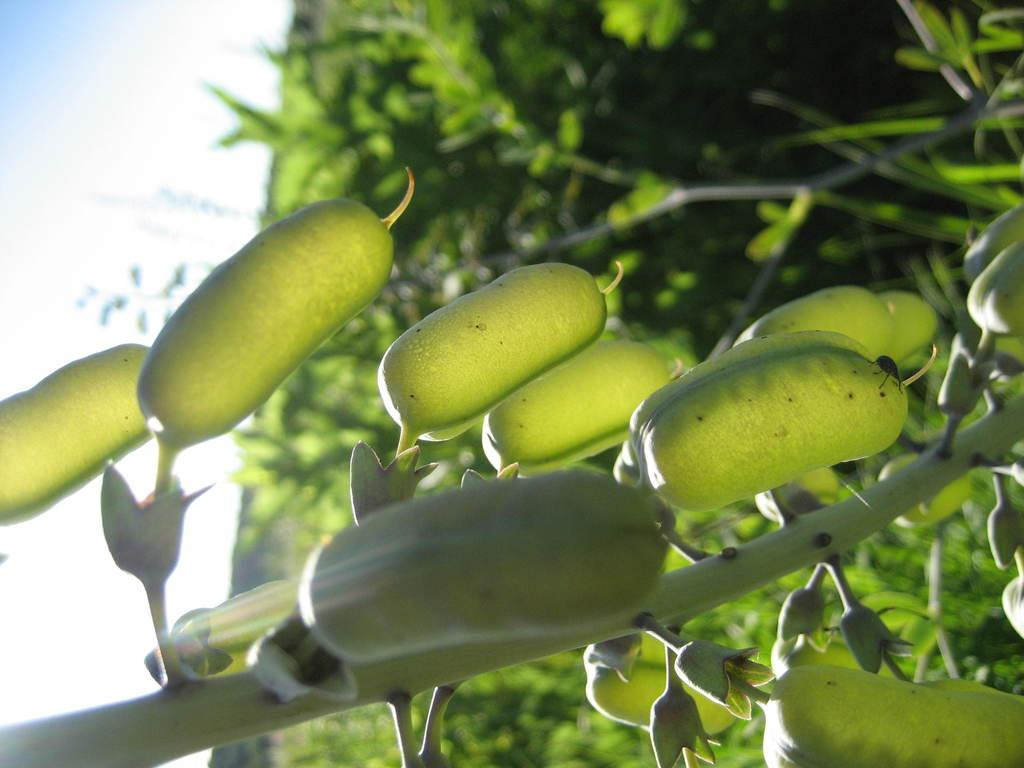What type of food is visible on the branch in the image? There are vegetables on a branch in the image. Can you describe the background of the image? The background of the image is blurred. What type of orange is being held by the family in the image? There is no orange or family present in the image; it only features vegetables on a branch with a blurred background. 